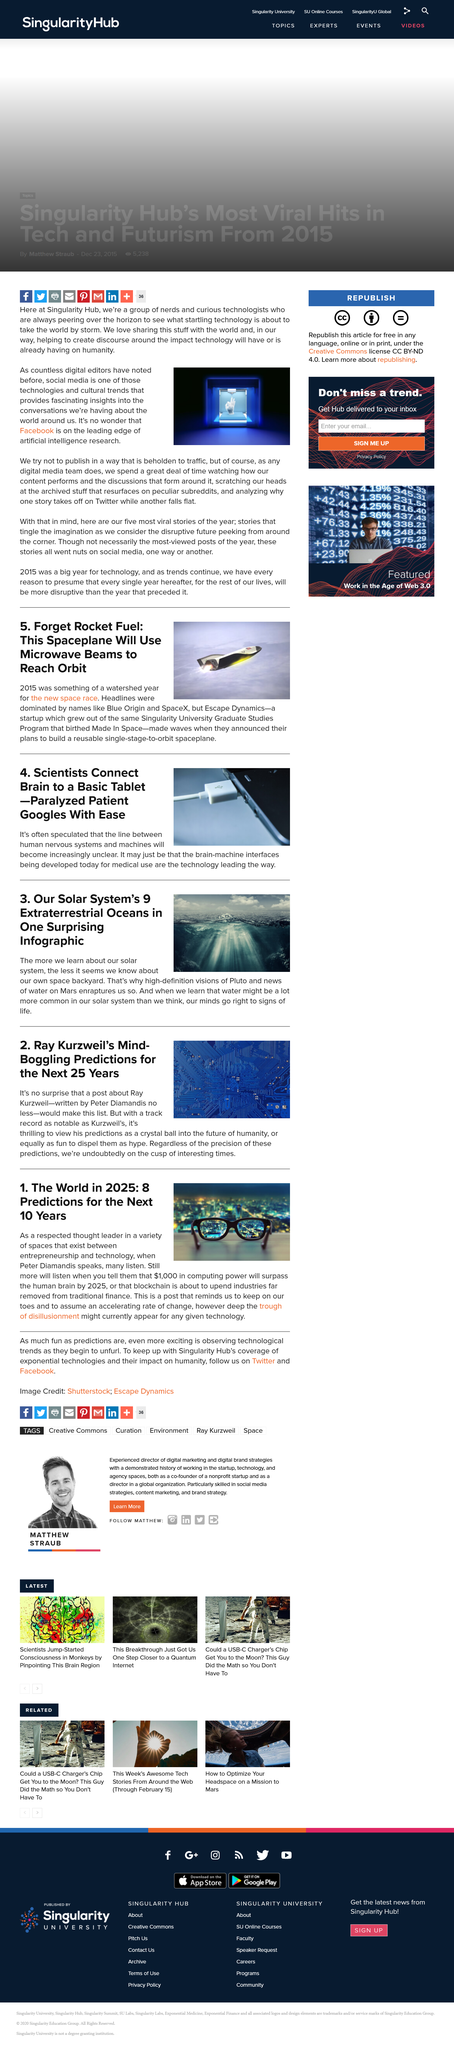Point out several critical features in this image. Facebook is at the forefront of artificial intelligence research. They spend a great deal of time watching how their content performs and the discussions that form around it. The name of this company is Singularity Hub. 